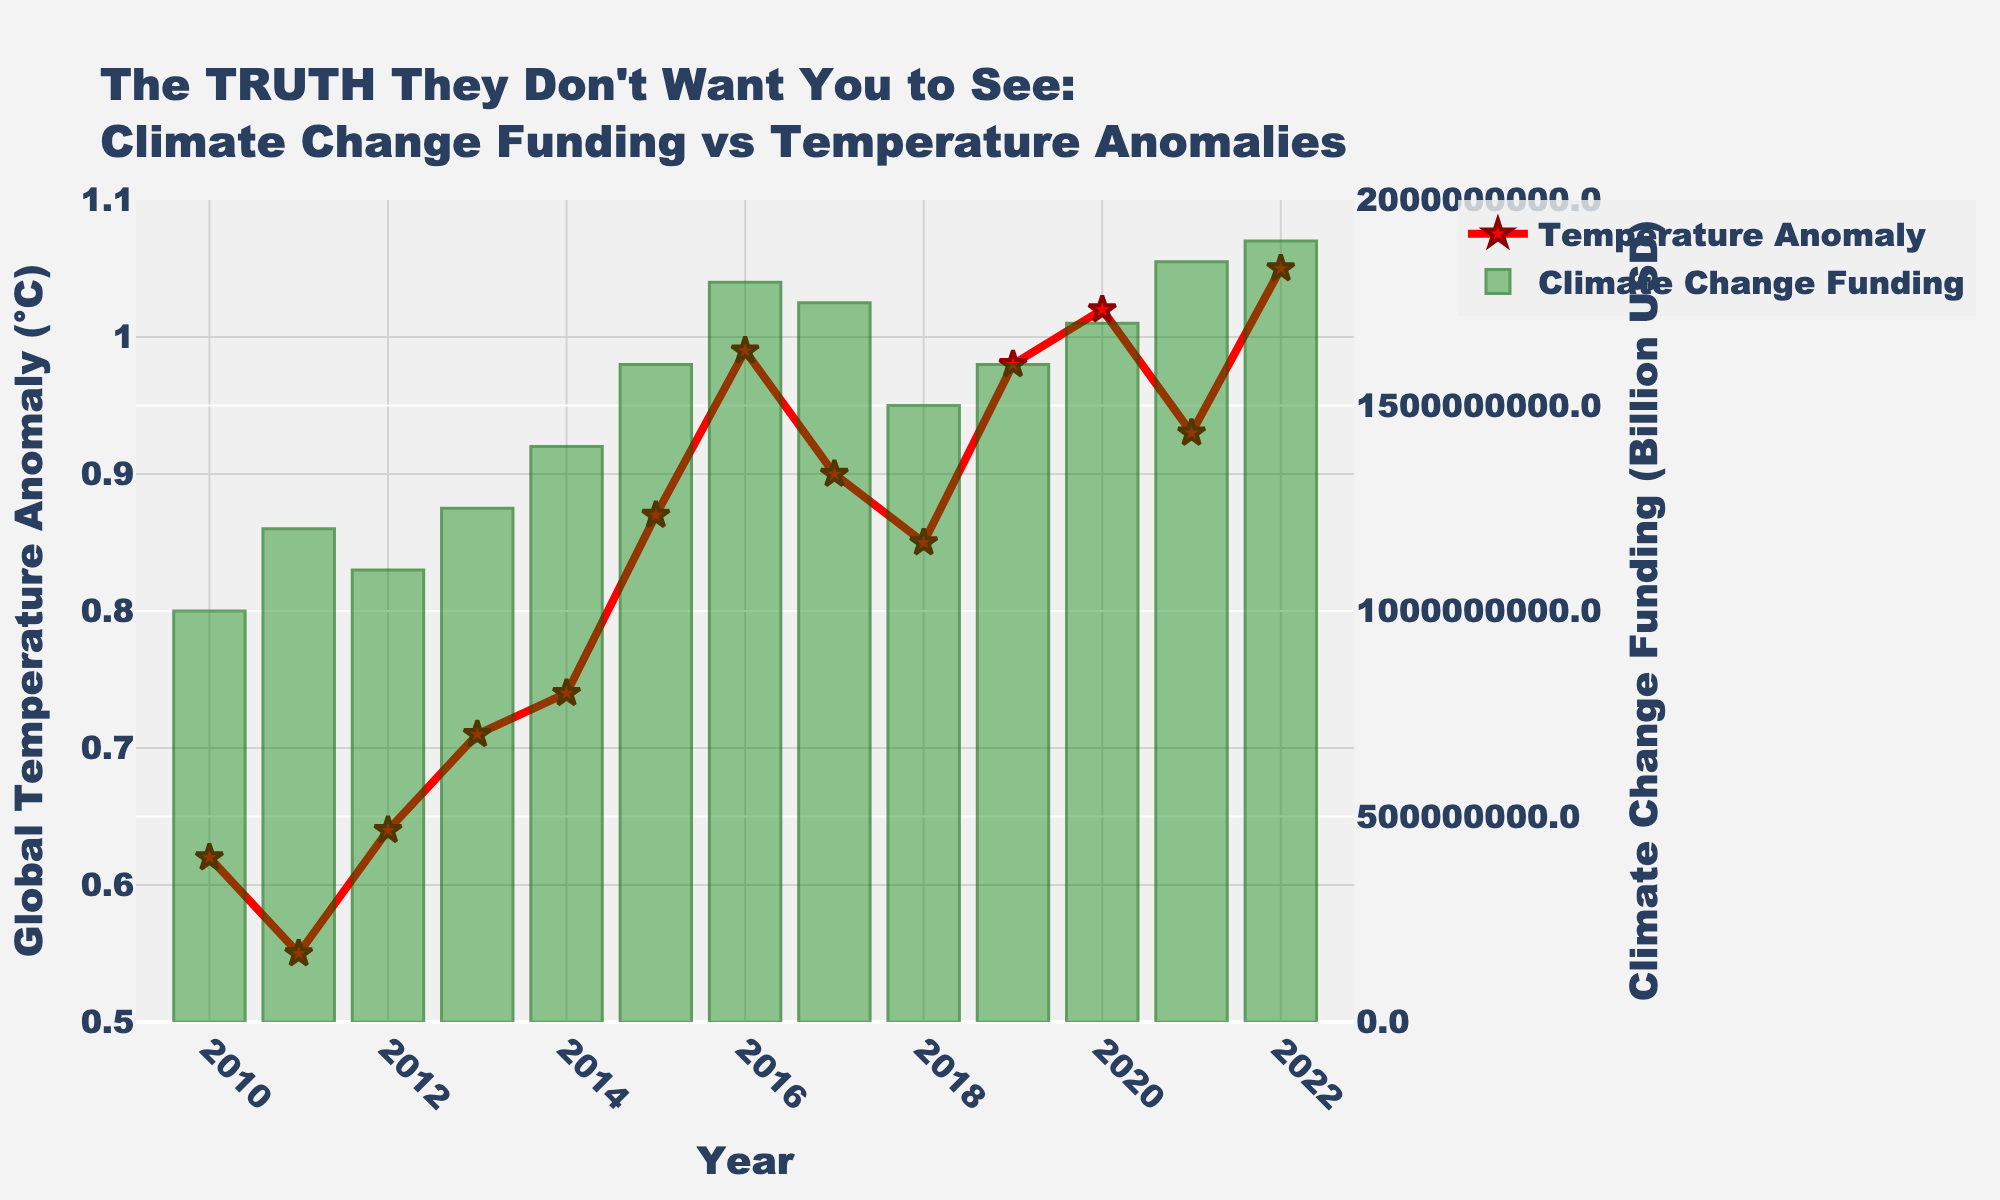What is the title of the figure? The title of the figure can be found at the top of the plot. It reads: "The TRUTH They Don't Want You to See: Climate Change Funding vs Temperature Anomalies."
Answer: The TRUTH They Don't Want You to See: Climate Change Funding vs Temperature Anomalies How many unique years are represented in the figure? To determine the number of unique years, count the x-axis labels. Each year from 2010 to 2022 is represented, making a total of 13 years.
Answer: 13 What is the color of the bars representing Climate Change Funding? The color of the bars can be observed directly. They are predominantly green with a semi-transparent appearance.
Answer: Green Which year had the highest Global Temperature Anomaly? The highest point on the line representing Global Temperature Anomaly can be identified by visual inspection. The year with the highest anomaly is 2022.
Answer: 2022 What is the Global Temperature Anomaly value in 2015? Identify the year 2015 on the x-axis, then follow the corresponding line point to see its value on the y-axis. It is 0.87°C.
Answer: 0.87°C In which year did Climate Change Funding peak? The height of the bars represents Climate Change Funding. The tallest bar represents the peak year, which is 2022.
Answer: 2022 Compare the Global Temperature Anomaly values between 2013 and 2014. Which year is higher? Locate the line points for 2013 and 2014 on the plot. The value in 2014 (0.74°C) is higher than that in 2013 (0.71°C).
Answer: 2014 Is there a year when Climate Change Funding decreased compared to the previous year? Observe the height of the bars year by year. The funding decreased in 2018 compared to 2017.
Answer: Yes, in 2018 How did the Global Temperature Anomaly value change from 2019 to 2020? Locate the points for the years 2019 and 2020 on the line. The value increased from 0.98°C in 2019 to 1.02°C in 2020.
Answer: Increased Calculate the average Global Temperature Anomaly from 2010 to 2015. Add the anomaly values from these years: (0.62 + 0.55 + 0.64 + 0.71 + 0.74 + 0.87). The total is 4.13. Divide by the number of years (6). 4.13 / 6 = 0.69°C.
Answer: 0.69°C 